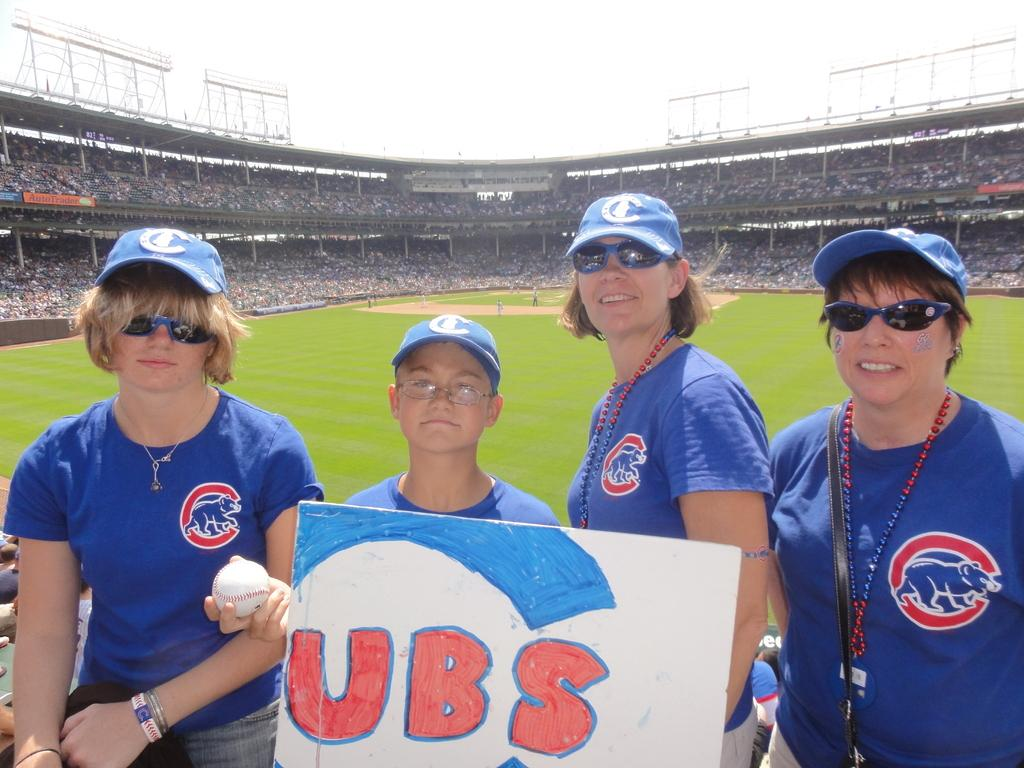<image>
Give a short and clear explanation of the subsequent image. A boy holding a sign that is for the Cubs 